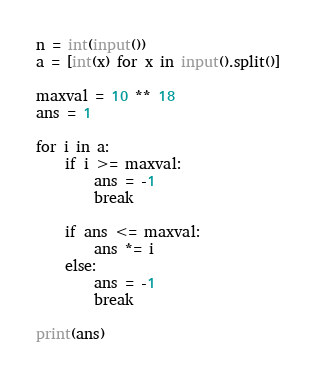<code> <loc_0><loc_0><loc_500><loc_500><_Python_>n = int(input())
a = [int(x) for x in input().split()]

maxval = 10 ** 18
ans = 1

for i in a:
    if i >= maxval:
        ans = -1
        break

    if ans <= maxval:
        ans *= i
    else:
        ans = -1
        break

print(ans)
</code> 